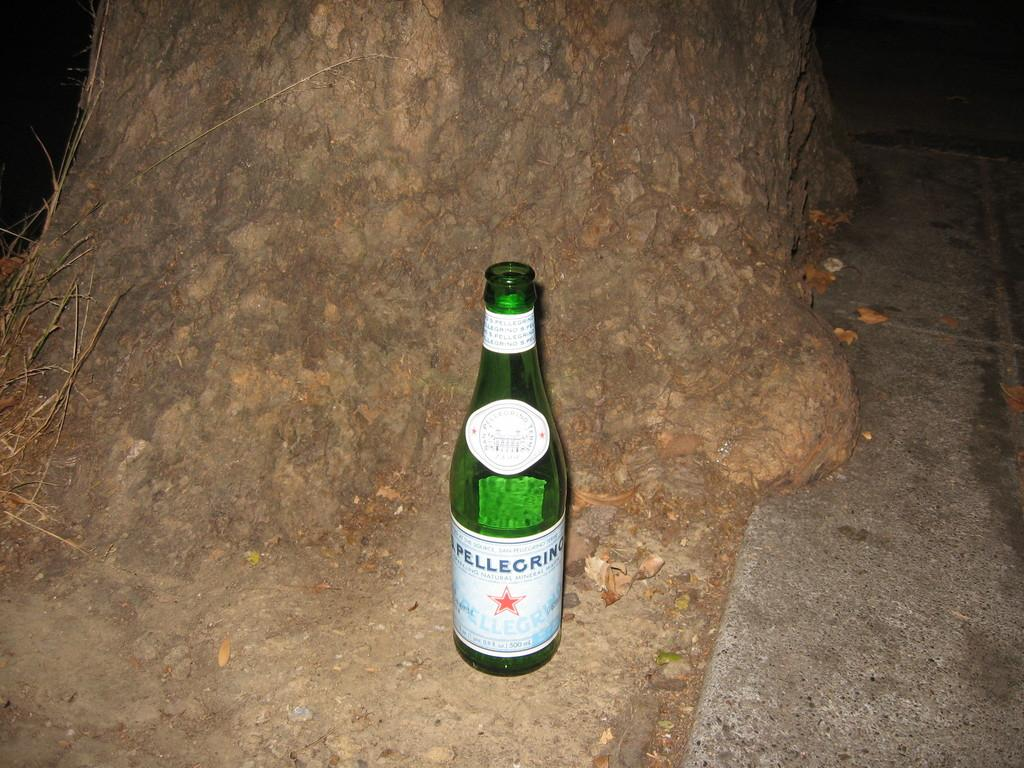<image>
Render a clear and concise summary of the photo. A pellegrino bottle that is sitting next to a tree. 